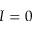<formula> <loc_0><loc_0><loc_500><loc_500>I = 0</formula> 